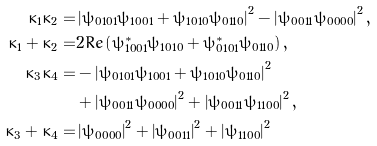Convert formula to latex. <formula><loc_0><loc_0><loc_500><loc_500>\kappa _ { 1 } \kappa _ { 2 } = & \left | \psi _ { 0 1 0 1 } \psi _ { 1 0 0 1 } + \psi _ { 1 0 1 0 } \psi _ { 0 1 1 0 } \right | ^ { 2 } - \left | \psi _ { 0 0 1 1 } \psi _ { 0 0 0 0 } \right | ^ { 2 } , \\ \kappa _ { 1 } + \kappa _ { 2 } = & 2 R e \left ( \psi _ { 1 0 0 1 } ^ { * } \psi _ { 1 0 1 0 } + \psi _ { 0 1 0 1 } ^ { * } \psi _ { 0 1 1 0 } \right ) , \\ \kappa _ { 3 } \kappa _ { 4 } = & - \left | \psi _ { 0 1 0 1 } \psi _ { 1 0 0 1 } + \psi _ { 1 0 1 0 } \psi _ { 0 1 1 0 } \right | ^ { 2 } \\ & + \left | \psi _ { 0 0 1 1 } \psi _ { 0 0 0 0 } \right | ^ { 2 } + \left | \psi _ { 0 0 1 1 } \psi _ { 1 1 0 0 } \right | ^ { 2 } , \\ \kappa _ { 3 } + \kappa _ { 4 } = & \left | \psi _ { 0 0 0 0 } \right | ^ { 2 } + \left | \psi _ { 0 0 1 1 } \right | ^ { 2 } + \left | \psi _ { 1 1 0 0 } \right | ^ { 2 }</formula> 